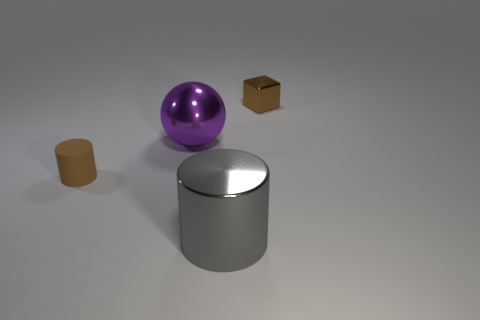How is the lighting in the image affecting the appearance of the objects? The lighting creates a soft shadow to the right of each object, enhancing the sense of three-dimensionality. It highlights the reflective surfaces of the sphere and the larger cylinder, emphasizing their shine, and reveals the texture differences between the matte and shiny surfaces. 